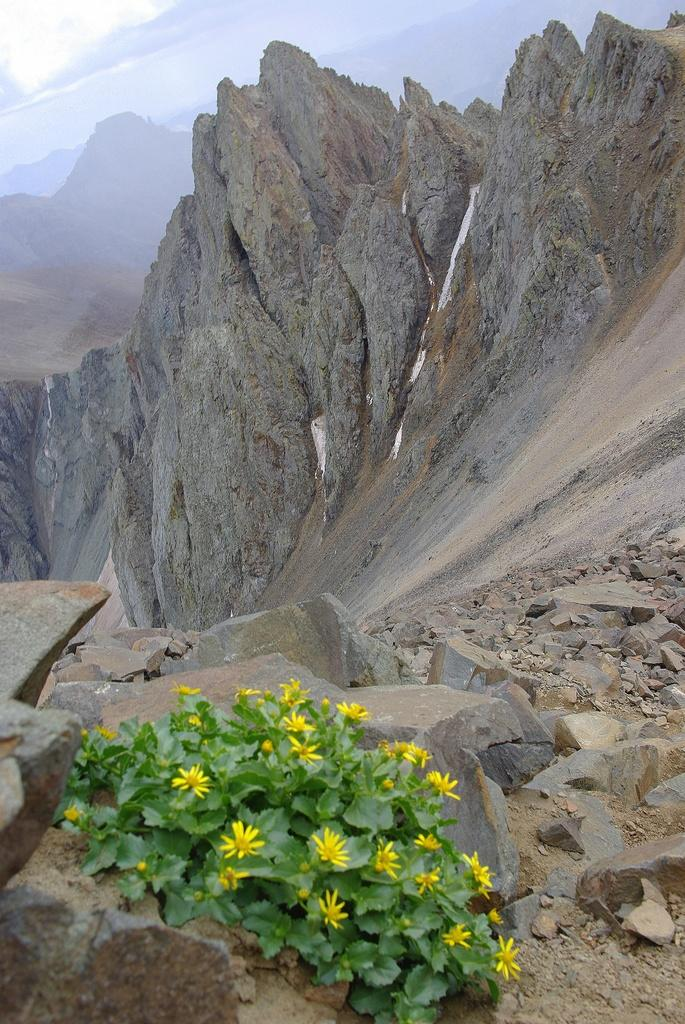What type of vegetation can be seen in the image? There are flowers and plants in the image. What can be found at the bottom of the image? There are stones at the bottom of the image. What is visible at the top of the image? The sky is visible at the top of the image. What type of jeans is the island wearing in the image? There is no island or clothing present in the image. 